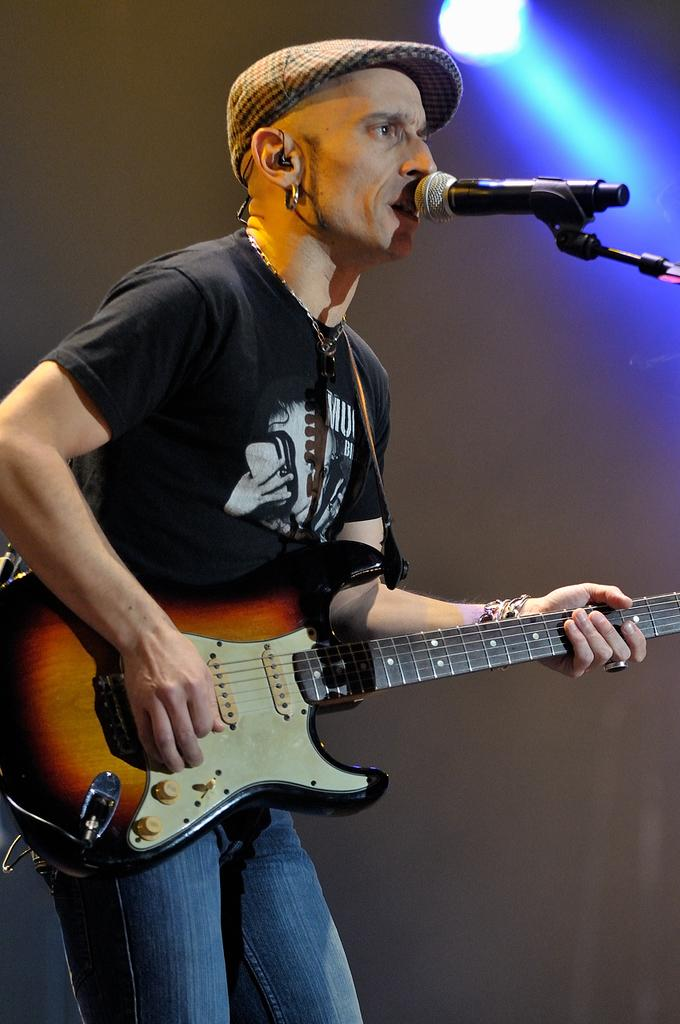What is the man in the image holding? The man is holding a guitar. What is the man standing near in the image? The man is standing in front of a microphone. Can you describe any other objects or features in the image? There is a light visible in the image. How does the man use honey to play the guitar in the image? There is no honey present in the image, and the man is not using any substance to play the guitar. 